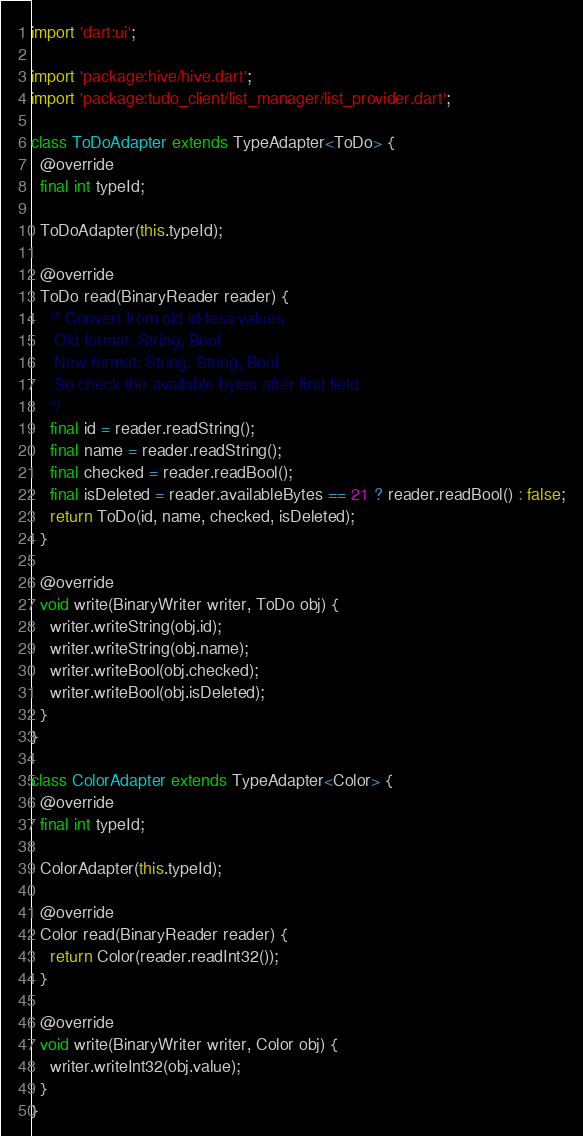<code> <loc_0><loc_0><loc_500><loc_500><_Dart_>import 'dart:ui';

import 'package:hive/hive.dart';
import 'package:tudo_client/list_manager/list_provider.dart';

class ToDoAdapter extends TypeAdapter<ToDo> {
  @override
  final int typeId;

  ToDoAdapter(this.typeId);

  @override
  ToDo read(BinaryReader reader) {
    /* Convert from old id-less values
     Old format: String, Bool
     New format: String, String, Bool
     So check the available bytes after first field
    */
    final id = reader.readString();
    final name = reader.readString();
    final checked = reader.readBool();
    final isDeleted = reader.availableBytes == 21 ? reader.readBool() : false;
    return ToDo(id, name, checked, isDeleted);
  }

  @override
  void write(BinaryWriter writer, ToDo obj) {
    writer.writeString(obj.id);
    writer.writeString(obj.name);
    writer.writeBool(obj.checked);
    writer.writeBool(obj.isDeleted);
  }
}

class ColorAdapter extends TypeAdapter<Color> {
  @override
  final int typeId;

  ColorAdapter(this.typeId);

  @override
  Color read(BinaryReader reader) {
    return Color(reader.readInt32());
  }

  @override
  void write(BinaryWriter writer, Color obj) {
    writer.writeInt32(obj.value);
  }
}
</code> 